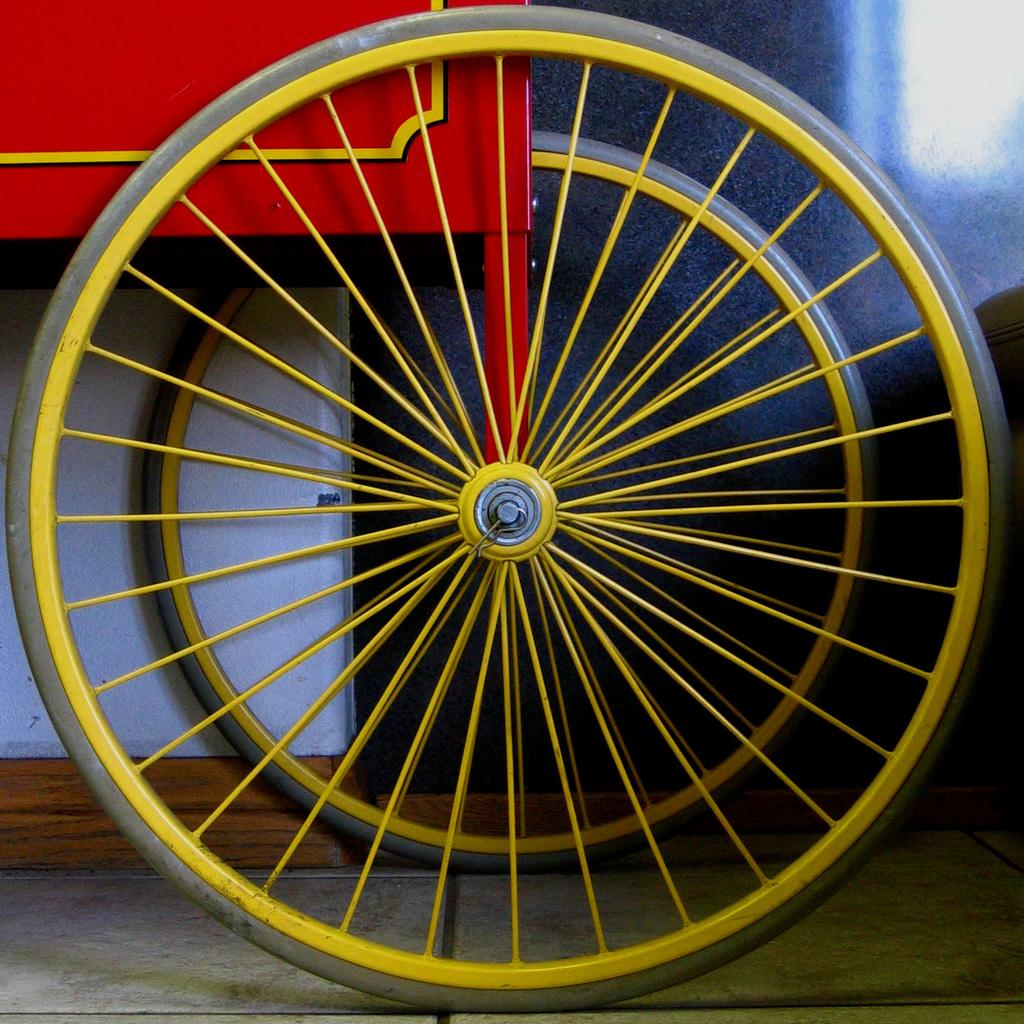What is the main object in the image? There is an object that looks like a cart in the image. What can be seen in the background of the image? There is a wall in the background of the image. What type of science experiment is being conducted on the cart in the image? There is no science experiment or any indication of scientific activity in the image; it only features a cart-like object and a wall in the background. 